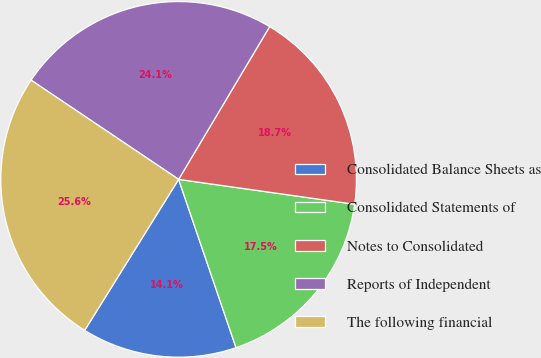Convert chart. <chart><loc_0><loc_0><loc_500><loc_500><pie_chart><fcel>Consolidated Balance Sheets as<fcel>Consolidated Statements of<fcel>Notes to Consolidated<fcel>Reports of Independent<fcel>The following financial<nl><fcel>14.09%<fcel>17.53%<fcel>18.68%<fcel>24.13%<fcel>25.56%<nl></chart> 